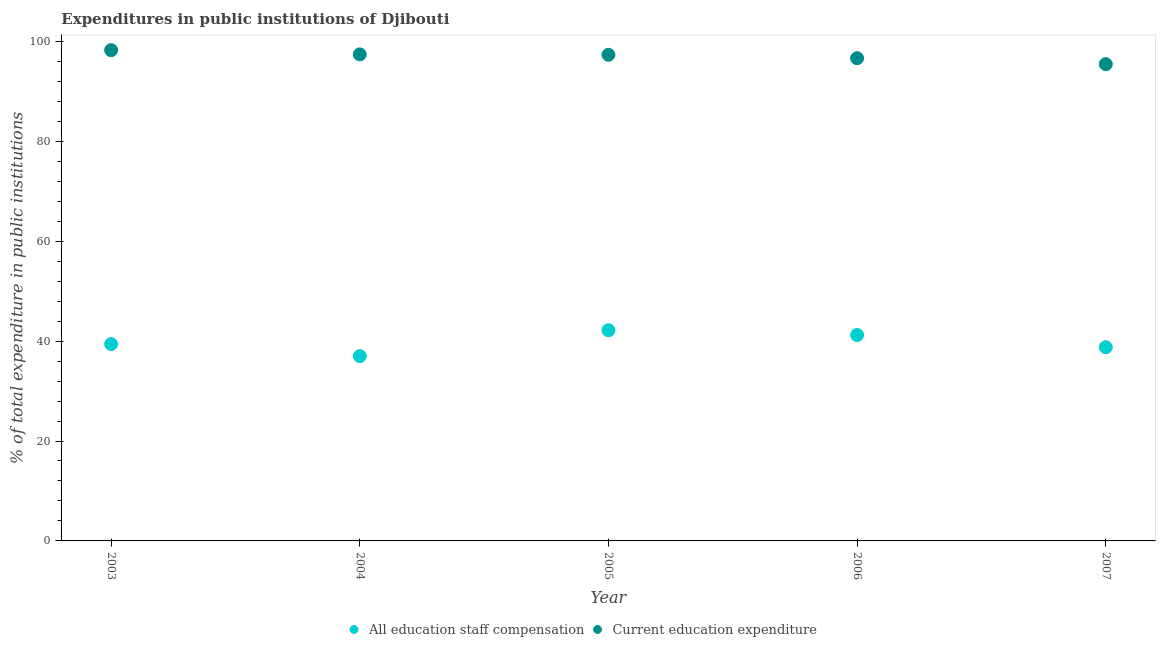How many different coloured dotlines are there?
Keep it short and to the point. 2. Is the number of dotlines equal to the number of legend labels?
Make the answer very short. Yes. What is the expenditure in staff compensation in 2004?
Ensure brevity in your answer.  36.99. Across all years, what is the maximum expenditure in staff compensation?
Provide a succinct answer. 42.17. Across all years, what is the minimum expenditure in education?
Give a very brief answer. 95.44. What is the total expenditure in staff compensation in the graph?
Offer a very short reply. 198.55. What is the difference between the expenditure in staff compensation in 2004 and that in 2005?
Make the answer very short. -5.18. What is the difference between the expenditure in education in 2007 and the expenditure in staff compensation in 2006?
Give a very brief answer. 54.23. What is the average expenditure in education per year?
Keep it short and to the point. 97. In the year 2007, what is the difference between the expenditure in staff compensation and expenditure in education?
Your answer should be compact. -56.67. What is the ratio of the expenditure in education in 2004 to that in 2006?
Your answer should be very brief. 1.01. What is the difference between the highest and the second highest expenditure in education?
Provide a succinct answer. 0.84. What is the difference between the highest and the lowest expenditure in staff compensation?
Ensure brevity in your answer.  5.18. In how many years, is the expenditure in education greater than the average expenditure in education taken over all years?
Your response must be concise. 3. Is the sum of the expenditure in education in 2003 and 2006 greater than the maximum expenditure in staff compensation across all years?
Your answer should be compact. Yes. Does the expenditure in education monotonically increase over the years?
Your answer should be compact. No. Is the expenditure in staff compensation strictly greater than the expenditure in education over the years?
Your answer should be very brief. No. Is the expenditure in staff compensation strictly less than the expenditure in education over the years?
Your answer should be very brief. Yes. How many years are there in the graph?
Your answer should be very brief. 5. What is the difference between two consecutive major ticks on the Y-axis?
Give a very brief answer. 20. What is the title of the graph?
Make the answer very short. Expenditures in public institutions of Djibouti. Does "Foreign Liabilities" appear as one of the legend labels in the graph?
Your response must be concise. No. What is the label or title of the X-axis?
Offer a terse response. Year. What is the label or title of the Y-axis?
Give a very brief answer. % of total expenditure in public institutions. What is the % of total expenditure in public institutions in All education staff compensation in 2003?
Offer a terse response. 39.4. What is the % of total expenditure in public institutions in Current education expenditure in 2003?
Your response must be concise. 98.23. What is the % of total expenditure in public institutions of All education staff compensation in 2004?
Provide a short and direct response. 36.99. What is the % of total expenditure in public institutions of Current education expenditure in 2004?
Your answer should be very brief. 97.39. What is the % of total expenditure in public institutions of All education staff compensation in 2005?
Offer a terse response. 42.17. What is the % of total expenditure in public institutions in Current education expenditure in 2005?
Make the answer very short. 97.31. What is the % of total expenditure in public institutions of All education staff compensation in 2006?
Make the answer very short. 41.21. What is the % of total expenditure in public institutions in Current education expenditure in 2006?
Your response must be concise. 96.62. What is the % of total expenditure in public institutions in All education staff compensation in 2007?
Ensure brevity in your answer.  38.77. What is the % of total expenditure in public institutions of Current education expenditure in 2007?
Make the answer very short. 95.44. Across all years, what is the maximum % of total expenditure in public institutions of All education staff compensation?
Provide a short and direct response. 42.17. Across all years, what is the maximum % of total expenditure in public institutions in Current education expenditure?
Offer a terse response. 98.23. Across all years, what is the minimum % of total expenditure in public institutions in All education staff compensation?
Offer a terse response. 36.99. Across all years, what is the minimum % of total expenditure in public institutions of Current education expenditure?
Offer a terse response. 95.44. What is the total % of total expenditure in public institutions in All education staff compensation in the graph?
Ensure brevity in your answer.  198.55. What is the total % of total expenditure in public institutions in Current education expenditure in the graph?
Offer a very short reply. 484.99. What is the difference between the % of total expenditure in public institutions of All education staff compensation in 2003 and that in 2004?
Provide a short and direct response. 2.41. What is the difference between the % of total expenditure in public institutions of Current education expenditure in 2003 and that in 2004?
Provide a short and direct response. 0.84. What is the difference between the % of total expenditure in public institutions of All education staff compensation in 2003 and that in 2005?
Provide a short and direct response. -2.77. What is the difference between the % of total expenditure in public institutions in Current education expenditure in 2003 and that in 2005?
Offer a very short reply. 0.93. What is the difference between the % of total expenditure in public institutions of All education staff compensation in 2003 and that in 2006?
Ensure brevity in your answer.  -1.81. What is the difference between the % of total expenditure in public institutions in Current education expenditure in 2003 and that in 2006?
Offer a very short reply. 1.61. What is the difference between the % of total expenditure in public institutions of All education staff compensation in 2003 and that in 2007?
Your answer should be very brief. 0.63. What is the difference between the % of total expenditure in public institutions in Current education expenditure in 2003 and that in 2007?
Your response must be concise. 2.8. What is the difference between the % of total expenditure in public institutions of All education staff compensation in 2004 and that in 2005?
Give a very brief answer. -5.18. What is the difference between the % of total expenditure in public institutions of Current education expenditure in 2004 and that in 2005?
Give a very brief answer. 0.09. What is the difference between the % of total expenditure in public institutions in All education staff compensation in 2004 and that in 2006?
Keep it short and to the point. -4.22. What is the difference between the % of total expenditure in public institutions of Current education expenditure in 2004 and that in 2006?
Your answer should be very brief. 0.77. What is the difference between the % of total expenditure in public institutions in All education staff compensation in 2004 and that in 2007?
Your answer should be compact. -1.78. What is the difference between the % of total expenditure in public institutions of Current education expenditure in 2004 and that in 2007?
Give a very brief answer. 1.95. What is the difference between the % of total expenditure in public institutions in All education staff compensation in 2005 and that in 2006?
Offer a terse response. 0.96. What is the difference between the % of total expenditure in public institutions in Current education expenditure in 2005 and that in 2006?
Your answer should be very brief. 0.68. What is the difference between the % of total expenditure in public institutions of All education staff compensation in 2005 and that in 2007?
Make the answer very short. 3.4. What is the difference between the % of total expenditure in public institutions of Current education expenditure in 2005 and that in 2007?
Your answer should be compact. 1.87. What is the difference between the % of total expenditure in public institutions of All education staff compensation in 2006 and that in 2007?
Ensure brevity in your answer.  2.44. What is the difference between the % of total expenditure in public institutions in Current education expenditure in 2006 and that in 2007?
Offer a terse response. 1.19. What is the difference between the % of total expenditure in public institutions in All education staff compensation in 2003 and the % of total expenditure in public institutions in Current education expenditure in 2004?
Keep it short and to the point. -57.99. What is the difference between the % of total expenditure in public institutions of All education staff compensation in 2003 and the % of total expenditure in public institutions of Current education expenditure in 2005?
Make the answer very short. -57.91. What is the difference between the % of total expenditure in public institutions in All education staff compensation in 2003 and the % of total expenditure in public institutions in Current education expenditure in 2006?
Your answer should be compact. -57.22. What is the difference between the % of total expenditure in public institutions in All education staff compensation in 2003 and the % of total expenditure in public institutions in Current education expenditure in 2007?
Provide a short and direct response. -56.04. What is the difference between the % of total expenditure in public institutions in All education staff compensation in 2004 and the % of total expenditure in public institutions in Current education expenditure in 2005?
Provide a succinct answer. -60.31. What is the difference between the % of total expenditure in public institutions in All education staff compensation in 2004 and the % of total expenditure in public institutions in Current education expenditure in 2006?
Make the answer very short. -59.63. What is the difference between the % of total expenditure in public institutions of All education staff compensation in 2004 and the % of total expenditure in public institutions of Current education expenditure in 2007?
Keep it short and to the point. -58.44. What is the difference between the % of total expenditure in public institutions of All education staff compensation in 2005 and the % of total expenditure in public institutions of Current education expenditure in 2006?
Ensure brevity in your answer.  -54.45. What is the difference between the % of total expenditure in public institutions in All education staff compensation in 2005 and the % of total expenditure in public institutions in Current education expenditure in 2007?
Provide a succinct answer. -53.27. What is the difference between the % of total expenditure in public institutions in All education staff compensation in 2006 and the % of total expenditure in public institutions in Current education expenditure in 2007?
Offer a terse response. -54.23. What is the average % of total expenditure in public institutions of All education staff compensation per year?
Offer a terse response. 39.71. What is the average % of total expenditure in public institutions in Current education expenditure per year?
Provide a succinct answer. 97. In the year 2003, what is the difference between the % of total expenditure in public institutions in All education staff compensation and % of total expenditure in public institutions in Current education expenditure?
Offer a terse response. -58.83. In the year 2004, what is the difference between the % of total expenditure in public institutions in All education staff compensation and % of total expenditure in public institutions in Current education expenditure?
Your answer should be compact. -60.4. In the year 2005, what is the difference between the % of total expenditure in public institutions of All education staff compensation and % of total expenditure in public institutions of Current education expenditure?
Offer a very short reply. -55.14. In the year 2006, what is the difference between the % of total expenditure in public institutions in All education staff compensation and % of total expenditure in public institutions in Current education expenditure?
Your answer should be compact. -55.41. In the year 2007, what is the difference between the % of total expenditure in public institutions of All education staff compensation and % of total expenditure in public institutions of Current education expenditure?
Give a very brief answer. -56.67. What is the ratio of the % of total expenditure in public institutions in All education staff compensation in 2003 to that in 2004?
Ensure brevity in your answer.  1.07. What is the ratio of the % of total expenditure in public institutions of Current education expenditure in 2003 to that in 2004?
Give a very brief answer. 1.01. What is the ratio of the % of total expenditure in public institutions in All education staff compensation in 2003 to that in 2005?
Your answer should be very brief. 0.93. What is the ratio of the % of total expenditure in public institutions in Current education expenditure in 2003 to that in 2005?
Provide a short and direct response. 1.01. What is the ratio of the % of total expenditure in public institutions of All education staff compensation in 2003 to that in 2006?
Provide a succinct answer. 0.96. What is the ratio of the % of total expenditure in public institutions of Current education expenditure in 2003 to that in 2006?
Offer a terse response. 1.02. What is the ratio of the % of total expenditure in public institutions in All education staff compensation in 2003 to that in 2007?
Give a very brief answer. 1.02. What is the ratio of the % of total expenditure in public institutions of Current education expenditure in 2003 to that in 2007?
Offer a terse response. 1.03. What is the ratio of the % of total expenditure in public institutions of All education staff compensation in 2004 to that in 2005?
Provide a short and direct response. 0.88. What is the ratio of the % of total expenditure in public institutions in Current education expenditure in 2004 to that in 2005?
Ensure brevity in your answer.  1. What is the ratio of the % of total expenditure in public institutions in All education staff compensation in 2004 to that in 2006?
Offer a very short reply. 0.9. What is the ratio of the % of total expenditure in public institutions in Current education expenditure in 2004 to that in 2006?
Give a very brief answer. 1.01. What is the ratio of the % of total expenditure in public institutions in All education staff compensation in 2004 to that in 2007?
Offer a very short reply. 0.95. What is the ratio of the % of total expenditure in public institutions of Current education expenditure in 2004 to that in 2007?
Keep it short and to the point. 1.02. What is the ratio of the % of total expenditure in public institutions of All education staff compensation in 2005 to that in 2006?
Offer a very short reply. 1.02. What is the ratio of the % of total expenditure in public institutions in Current education expenditure in 2005 to that in 2006?
Give a very brief answer. 1.01. What is the ratio of the % of total expenditure in public institutions of All education staff compensation in 2005 to that in 2007?
Offer a terse response. 1.09. What is the ratio of the % of total expenditure in public institutions of Current education expenditure in 2005 to that in 2007?
Offer a terse response. 1.02. What is the ratio of the % of total expenditure in public institutions of All education staff compensation in 2006 to that in 2007?
Offer a terse response. 1.06. What is the ratio of the % of total expenditure in public institutions of Current education expenditure in 2006 to that in 2007?
Your answer should be very brief. 1.01. What is the difference between the highest and the second highest % of total expenditure in public institutions in All education staff compensation?
Your answer should be very brief. 0.96. What is the difference between the highest and the second highest % of total expenditure in public institutions in Current education expenditure?
Your answer should be compact. 0.84. What is the difference between the highest and the lowest % of total expenditure in public institutions of All education staff compensation?
Provide a succinct answer. 5.18. What is the difference between the highest and the lowest % of total expenditure in public institutions of Current education expenditure?
Your answer should be compact. 2.8. 